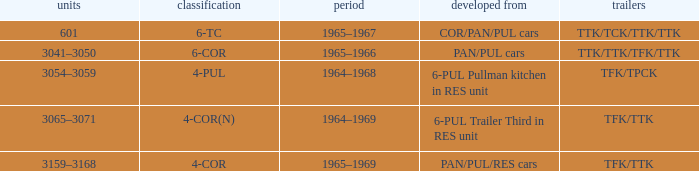Name the formed that has type of 4-cor PAN/PUL/RES cars. 